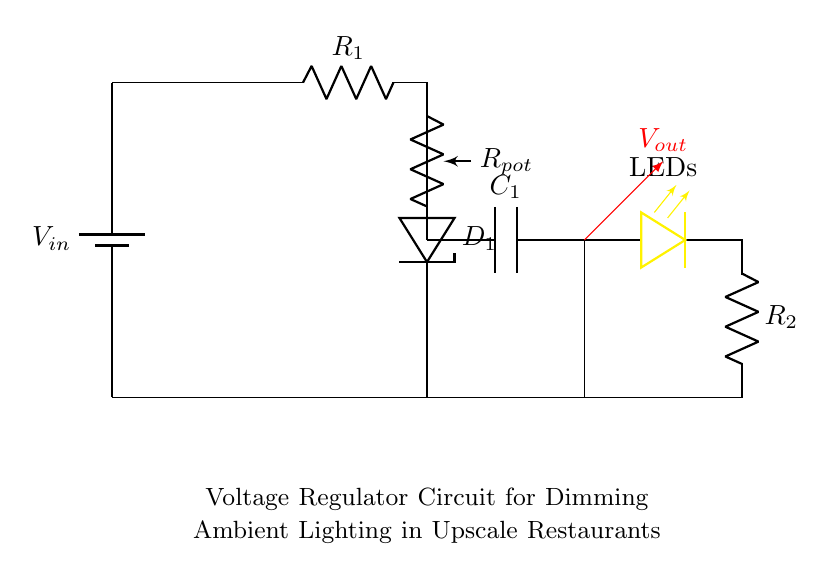What is the input voltage for this circuit? The circuit diagram shows a battery labeled V_in, which is the source of input voltage. There is no specific voltage value indicated in the diagram; thus, it is denoted as V_in.
Answer: V_in What component is responsible for dimming the lights? The potentiometer, labeled R_pot, is directly connected to the LED string and adjusts the resistance in the circuit, controlling the current flow and thereby dimming the lights.
Answer: R_pot How many resistors are in the circuit? In the circuit, there are two resistors indicated as R_1 and R_2. Counting the resistors shows that there are two total.
Answer: 2 What is the role of the capacitor in this circuit? The capacitor, labeled C_1, serves to smooth the output voltage by filtering out fluctuations and ensuring a more stable voltage is delivered to the LED string.
Answer: Smooth output voltage What is the output voltage connection point labeled in the circuit? The output voltage connection point is indicated by the red arrow pointing towards V_out, which is situated above the output capacitor and LED string.
Answer: V_out What happens if the potentiometer is adjusted to maximum resistance? Increasing the resistance of the potentiometer limits the current flowing through the circuit, which would cause the LEDs to dim significantly or turn off completely if resistance is very high.
Answer: LEDs dim 